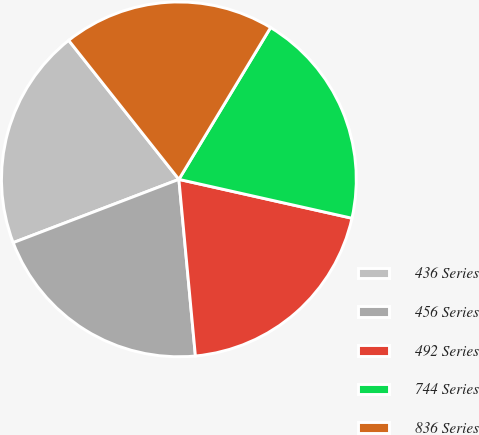Convert chart. <chart><loc_0><loc_0><loc_500><loc_500><pie_chart><fcel>436 Series<fcel>456 Series<fcel>492 Series<fcel>744 Series<fcel>836 Series<nl><fcel>20.14%<fcel>20.68%<fcel>20.0%<fcel>19.87%<fcel>19.32%<nl></chart> 